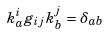<formula> <loc_0><loc_0><loc_500><loc_500>k ^ { i } _ { a } g _ { i j } k ^ { j } _ { b } = \delta _ { a b }</formula> 